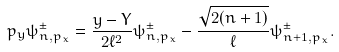<formula> <loc_0><loc_0><loc_500><loc_500>p _ { y } \psi ^ { \pm } _ { n , p _ { x } } = \frac { y - Y } { 2 \ell ^ { 2 } } \psi ^ { \pm } _ { n , p _ { x } } - \frac { \sqrt { 2 ( n + 1 ) } } { \ell } \psi ^ { \pm } _ { n + 1 , p _ { x } } .</formula> 